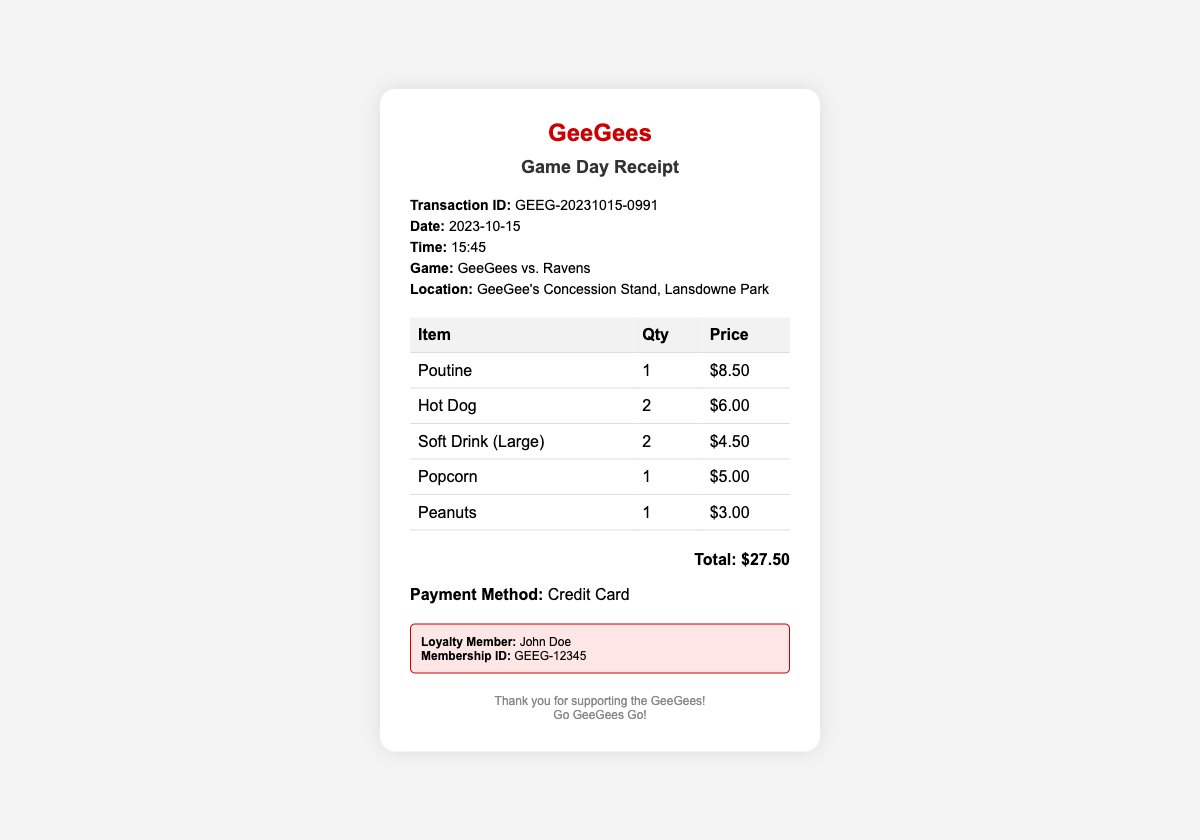What is the transaction ID? The transaction ID is a unique identifier for the receipt provided in the document.
Answer: GEEG-20231015-0991 What is the date of the game? The date indicates when the game and the associated transactions took place, which is specified in the details section.
Answer: 2023-10-15 How many soft drinks were purchased? This information reflects the quantity of soft drinks bought, listed in the items table.
Answer: 2 What is the total amount spent? The total amount is the sum of all individual item prices listed and is specifically noted at the bottom of the receipt.
Answer: $27.50 Who is the loyalty member? The loyalty member is identified in the receipt along with their membership details.
Answer: John Doe How many hot dogs were bought? The number of hot dogs is indicated next to the item in the receipt's table.
Answer: 2 What game was being played? The game title signifies the matchup of the teams on that specific game day and is recorded in the details section.
Answer: GeeGees vs. Ravens What location is mentioned on the receipt? The location denotes where the transactions occurred, which is specified in the details section of the document.
Answer: GeeGee's Concession Stand, Lansdowne Park What payment method was used? The payment method identifies how the transaction was completed and is stated in the details section.
Answer: Credit Card 